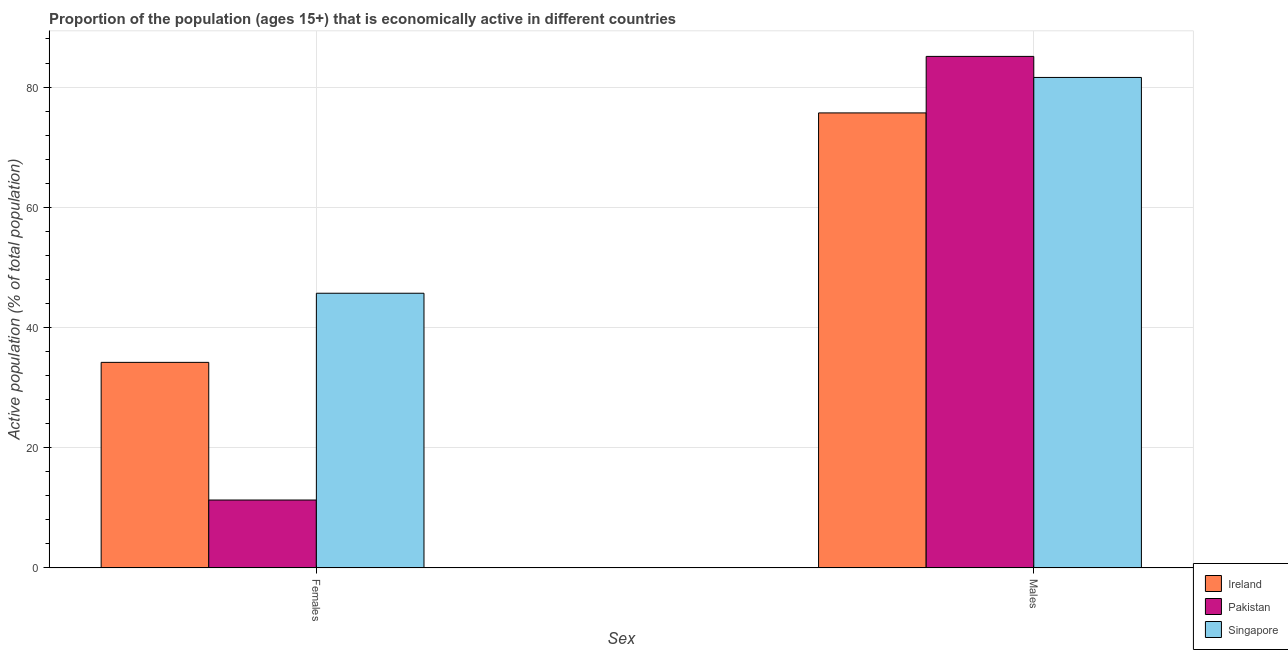How many groups of bars are there?
Your answer should be very brief. 2. Are the number of bars on each tick of the X-axis equal?
Give a very brief answer. Yes. How many bars are there on the 1st tick from the left?
Make the answer very short. 3. How many bars are there on the 1st tick from the right?
Keep it short and to the point. 3. What is the label of the 1st group of bars from the left?
Keep it short and to the point. Females. What is the percentage of economically active male population in Ireland?
Keep it short and to the point. 75.7. Across all countries, what is the maximum percentage of economically active male population?
Offer a terse response. 85.1. Across all countries, what is the minimum percentage of economically active male population?
Your answer should be very brief. 75.7. In which country was the percentage of economically active male population maximum?
Provide a short and direct response. Pakistan. In which country was the percentage of economically active male population minimum?
Offer a terse response. Ireland. What is the total percentage of economically active male population in the graph?
Your answer should be compact. 242.4. What is the difference between the percentage of economically active male population in Ireland and that in Pakistan?
Keep it short and to the point. -9.4. What is the difference between the percentage of economically active male population in Singapore and the percentage of economically active female population in Ireland?
Your answer should be compact. 47.4. What is the average percentage of economically active female population per country?
Your answer should be very brief. 30.4. What is the difference between the percentage of economically active male population and percentage of economically active female population in Ireland?
Provide a short and direct response. 41.5. What is the ratio of the percentage of economically active female population in Ireland to that in Singapore?
Make the answer very short. 0.75. In how many countries, is the percentage of economically active female population greater than the average percentage of economically active female population taken over all countries?
Your answer should be very brief. 2. What does the 1st bar from the left in Males represents?
Provide a succinct answer. Ireland. What does the 1st bar from the right in Females represents?
Provide a short and direct response. Singapore. How many bars are there?
Your answer should be very brief. 6. What is the difference between two consecutive major ticks on the Y-axis?
Your answer should be compact. 20. Are the values on the major ticks of Y-axis written in scientific E-notation?
Provide a short and direct response. No. Does the graph contain grids?
Your response must be concise. Yes. How are the legend labels stacked?
Your answer should be compact. Vertical. What is the title of the graph?
Your answer should be very brief. Proportion of the population (ages 15+) that is economically active in different countries. What is the label or title of the X-axis?
Your response must be concise. Sex. What is the label or title of the Y-axis?
Make the answer very short. Active population (% of total population). What is the Active population (% of total population) in Ireland in Females?
Ensure brevity in your answer.  34.2. What is the Active population (% of total population) of Pakistan in Females?
Give a very brief answer. 11.3. What is the Active population (% of total population) in Singapore in Females?
Your response must be concise. 45.7. What is the Active population (% of total population) of Ireland in Males?
Ensure brevity in your answer.  75.7. What is the Active population (% of total population) in Pakistan in Males?
Make the answer very short. 85.1. What is the Active population (% of total population) in Singapore in Males?
Offer a terse response. 81.6. Across all Sex, what is the maximum Active population (% of total population) in Ireland?
Give a very brief answer. 75.7. Across all Sex, what is the maximum Active population (% of total population) in Pakistan?
Provide a succinct answer. 85.1. Across all Sex, what is the maximum Active population (% of total population) in Singapore?
Provide a short and direct response. 81.6. Across all Sex, what is the minimum Active population (% of total population) in Ireland?
Give a very brief answer. 34.2. Across all Sex, what is the minimum Active population (% of total population) in Pakistan?
Make the answer very short. 11.3. Across all Sex, what is the minimum Active population (% of total population) in Singapore?
Offer a very short reply. 45.7. What is the total Active population (% of total population) of Ireland in the graph?
Provide a short and direct response. 109.9. What is the total Active population (% of total population) of Pakistan in the graph?
Provide a short and direct response. 96.4. What is the total Active population (% of total population) of Singapore in the graph?
Your answer should be compact. 127.3. What is the difference between the Active population (% of total population) of Ireland in Females and that in Males?
Ensure brevity in your answer.  -41.5. What is the difference between the Active population (% of total population) in Pakistan in Females and that in Males?
Your answer should be very brief. -73.8. What is the difference between the Active population (% of total population) in Singapore in Females and that in Males?
Ensure brevity in your answer.  -35.9. What is the difference between the Active population (% of total population) in Ireland in Females and the Active population (% of total population) in Pakistan in Males?
Keep it short and to the point. -50.9. What is the difference between the Active population (% of total population) in Ireland in Females and the Active population (% of total population) in Singapore in Males?
Your answer should be very brief. -47.4. What is the difference between the Active population (% of total population) in Pakistan in Females and the Active population (% of total population) in Singapore in Males?
Your answer should be very brief. -70.3. What is the average Active population (% of total population) in Ireland per Sex?
Give a very brief answer. 54.95. What is the average Active population (% of total population) in Pakistan per Sex?
Offer a terse response. 48.2. What is the average Active population (% of total population) of Singapore per Sex?
Offer a very short reply. 63.65. What is the difference between the Active population (% of total population) in Ireland and Active population (% of total population) in Pakistan in Females?
Provide a succinct answer. 22.9. What is the difference between the Active population (% of total population) in Pakistan and Active population (% of total population) in Singapore in Females?
Offer a very short reply. -34.4. What is the difference between the Active population (% of total population) of Ireland and Active population (% of total population) of Singapore in Males?
Make the answer very short. -5.9. What is the difference between the Active population (% of total population) in Pakistan and Active population (% of total population) in Singapore in Males?
Your answer should be very brief. 3.5. What is the ratio of the Active population (% of total population) of Ireland in Females to that in Males?
Offer a terse response. 0.45. What is the ratio of the Active population (% of total population) of Pakistan in Females to that in Males?
Your answer should be very brief. 0.13. What is the ratio of the Active population (% of total population) in Singapore in Females to that in Males?
Provide a short and direct response. 0.56. What is the difference between the highest and the second highest Active population (% of total population) of Ireland?
Give a very brief answer. 41.5. What is the difference between the highest and the second highest Active population (% of total population) in Pakistan?
Make the answer very short. 73.8. What is the difference between the highest and the second highest Active population (% of total population) of Singapore?
Ensure brevity in your answer.  35.9. What is the difference between the highest and the lowest Active population (% of total population) in Ireland?
Your answer should be compact. 41.5. What is the difference between the highest and the lowest Active population (% of total population) of Pakistan?
Offer a terse response. 73.8. What is the difference between the highest and the lowest Active population (% of total population) of Singapore?
Keep it short and to the point. 35.9. 